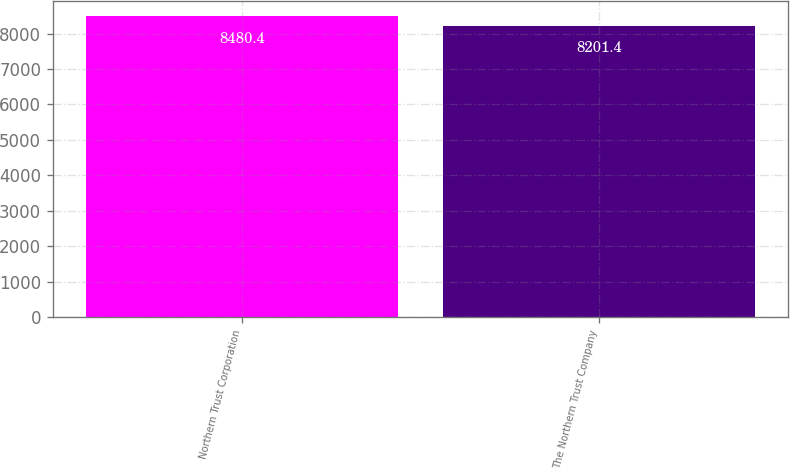Convert chart to OTSL. <chart><loc_0><loc_0><loc_500><loc_500><bar_chart><fcel>Northern Trust Corporation<fcel>The Northern Trust Company<nl><fcel>8480.4<fcel>8201.4<nl></chart> 